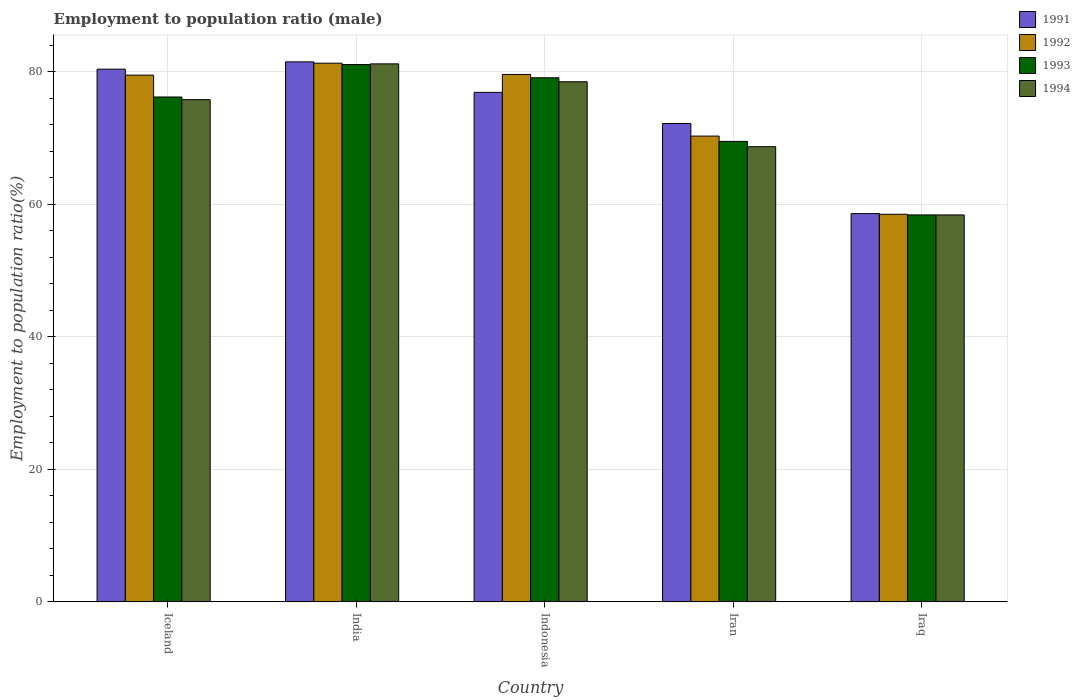How many groups of bars are there?
Provide a short and direct response. 5. Are the number of bars on each tick of the X-axis equal?
Make the answer very short. Yes. How many bars are there on the 1st tick from the right?
Your answer should be very brief. 4. What is the employment to population ratio in 1992 in India?
Your response must be concise. 81.3. Across all countries, what is the maximum employment to population ratio in 1994?
Your answer should be very brief. 81.2. Across all countries, what is the minimum employment to population ratio in 1992?
Give a very brief answer. 58.5. In which country was the employment to population ratio in 1992 minimum?
Keep it short and to the point. Iraq. What is the total employment to population ratio in 1992 in the graph?
Your response must be concise. 369.2. What is the difference between the employment to population ratio in 1991 in India and that in Indonesia?
Your response must be concise. 4.6. What is the difference between the employment to population ratio in 1991 in Iraq and the employment to population ratio in 1994 in Iceland?
Your response must be concise. -17.2. What is the average employment to population ratio in 1994 per country?
Your answer should be very brief. 72.52. What is the difference between the employment to population ratio of/in 1994 and employment to population ratio of/in 1993 in Iceland?
Provide a succinct answer. -0.4. What is the ratio of the employment to population ratio in 1991 in Iceland to that in Indonesia?
Offer a terse response. 1.05. Is the difference between the employment to population ratio in 1994 in India and Iraq greater than the difference between the employment to population ratio in 1993 in India and Iraq?
Your response must be concise. Yes. What is the difference between the highest and the second highest employment to population ratio in 1993?
Your answer should be very brief. 4.9. What is the difference between the highest and the lowest employment to population ratio in 1991?
Your answer should be compact. 22.9. Is the sum of the employment to population ratio in 1991 in Iceland and India greater than the maximum employment to population ratio in 1994 across all countries?
Your response must be concise. Yes. Is it the case that in every country, the sum of the employment to population ratio in 1994 and employment to population ratio in 1992 is greater than the sum of employment to population ratio in 1993 and employment to population ratio in 1991?
Provide a succinct answer. No. What does the 2nd bar from the right in Iceland represents?
Your answer should be compact. 1993. Are all the bars in the graph horizontal?
Your response must be concise. No. How many countries are there in the graph?
Offer a terse response. 5. Are the values on the major ticks of Y-axis written in scientific E-notation?
Your response must be concise. No. Does the graph contain grids?
Your response must be concise. Yes. What is the title of the graph?
Provide a succinct answer. Employment to population ratio (male). What is the label or title of the X-axis?
Your answer should be very brief. Country. What is the Employment to population ratio(%) in 1991 in Iceland?
Your response must be concise. 80.4. What is the Employment to population ratio(%) of 1992 in Iceland?
Make the answer very short. 79.5. What is the Employment to population ratio(%) of 1993 in Iceland?
Your answer should be compact. 76.2. What is the Employment to population ratio(%) in 1994 in Iceland?
Your response must be concise. 75.8. What is the Employment to population ratio(%) of 1991 in India?
Make the answer very short. 81.5. What is the Employment to population ratio(%) in 1992 in India?
Keep it short and to the point. 81.3. What is the Employment to population ratio(%) of 1993 in India?
Ensure brevity in your answer.  81.1. What is the Employment to population ratio(%) in 1994 in India?
Provide a short and direct response. 81.2. What is the Employment to population ratio(%) of 1991 in Indonesia?
Make the answer very short. 76.9. What is the Employment to population ratio(%) in 1992 in Indonesia?
Make the answer very short. 79.6. What is the Employment to population ratio(%) in 1993 in Indonesia?
Keep it short and to the point. 79.1. What is the Employment to population ratio(%) of 1994 in Indonesia?
Ensure brevity in your answer.  78.5. What is the Employment to population ratio(%) of 1991 in Iran?
Provide a succinct answer. 72.2. What is the Employment to population ratio(%) of 1992 in Iran?
Your answer should be compact. 70.3. What is the Employment to population ratio(%) in 1993 in Iran?
Make the answer very short. 69.5. What is the Employment to population ratio(%) in 1994 in Iran?
Keep it short and to the point. 68.7. What is the Employment to population ratio(%) of 1991 in Iraq?
Give a very brief answer. 58.6. What is the Employment to population ratio(%) of 1992 in Iraq?
Provide a short and direct response. 58.5. What is the Employment to population ratio(%) in 1993 in Iraq?
Your answer should be very brief. 58.4. What is the Employment to population ratio(%) of 1994 in Iraq?
Provide a succinct answer. 58.4. Across all countries, what is the maximum Employment to population ratio(%) in 1991?
Keep it short and to the point. 81.5. Across all countries, what is the maximum Employment to population ratio(%) in 1992?
Offer a terse response. 81.3. Across all countries, what is the maximum Employment to population ratio(%) of 1993?
Ensure brevity in your answer.  81.1. Across all countries, what is the maximum Employment to population ratio(%) in 1994?
Provide a succinct answer. 81.2. Across all countries, what is the minimum Employment to population ratio(%) of 1991?
Provide a short and direct response. 58.6. Across all countries, what is the minimum Employment to population ratio(%) of 1992?
Offer a very short reply. 58.5. Across all countries, what is the minimum Employment to population ratio(%) of 1993?
Make the answer very short. 58.4. Across all countries, what is the minimum Employment to population ratio(%) in 1994?
Make the answer very short. 58.4. What is the total Employment to population ratio(%) of 1991 in the graph?
Your answer should be compact. 369.6. What is the total Employment to population ratio(%) in 1992 in the graph?
Your response must be concise. 369.2. What is the total Employment to population ratio(%) of 1993 in the graph?
Offer a terse response. 364.3. What is the total Employment to population ratio(%) of 1994 in the graph?
Keep it short and to the point. 362.6. What is the difference between the Employment to population ratio(%) in 1992 in Iceland and that in India?
Ensure brevity in your answer.  -1.8. What is the difference between the Employment to population ratio(%) in 1993 in Iceland and that in India?
Your response must be concise. -4.9. What is the difference between the Employment to population ratio(%) in 1992 in Iceland and that in Indonesia?
Offer a very short reply. -0.1. What is the difference between the Employment to population ratio(%) of 1993 in Iceland and that in Indonesia?
Offer a terse response. -2.9. What is the difference between the Employment to population ratio(%) in 1994 in Iceland and that in Indonesia?
Ensure brevity in your answer.  -2.7. What is the difference between the Employment to population ratio(%) in 1991 in Iceland and that in Iraq?
Your response must be concise. 21.8. What is the difference between the Employment to population ratio(%) of 1991 in India and that in Indonesia?
Offer a terse response. 4.6. What is the difference between the Employment to population ratio(%) in 1992 in India and that in Indonesia?
Your answer should be very brief. 1.7. What is the difference between the Employment to population ratio(%) of 1991 in India and that in Iran?
Keep it short and to the point. 9.3. What is the difference between the Employment to population ratio(%) in 1992 in India and that in Iran?
Keep it short and to the point. 11. What is the difference between the Employment to population ratio(%) of 1993 in India and that in Iran?
Offer a very short reply. 11.6. What is the difference between the Employment to population ratio(%) of 1994 in India and that in Iran?
Offer a very short reply. 12.5. What is the difference between the Employment to population ratio(%) of 1991 in India and that in Iraq?
Your answer should be compact. 22.9. What is the difference between the Employment to population ratio(%) in 1992 in India and that in Iraq?
Your response must be concise. 22.8. What is the difference between the Employment to population ratio(%) in 1993 in India and that in Iraq?
Give a very brief answer. 22.7. What is the difference between the Employment to population ratio(%) of 1994 in India and that in Iraq?
Provide a short and direct response. 22.8. What is the difference between the Employment to population ratio(%) in 1991 in Indonesia and that in Iran?
Ensure brevity in your answer.  4.7. What is the difference between the Employment to population ratio(%) in 1994 in Indonesia and that in Iran?
Provide a succinct answer. 9.8. What is the difference between the Employment to population ratio(%) in 1992 in Indonesia and that in Iraq?
Make the answer very short. 21.1. What is the difference between the Employment to population ratio(%) of 1993 in Indonesia and that in Iraq?
Your answer should be very brief. 20.7. What is the difference between the Employment to population ratio(%) in 1994 in Indonesia and that in Iraq?
Your answer should be compact. 20.1. What is the difference between the Employment to population ratio(%) in 1993 in Iran and that in Iraq?
Provide a short and direct response. 11.1. What is the difference between the Employment to population ratio(%) in 1991 in Iceland and the Employment to population ratio(%) in 1993 in India?
Provide a succinct answer. -0.7. What is the difference between the Employment to population ratio(%) of 1991 in Iceland and the Employment to population ratio(%) of 1994 in Indonesia?
Offer a terse response. 1.9. What is the difference between the Employment to population ratio(%) of 1991 in Iceland and the Employment to population ratio(%) of 1993 in Iran?
Offer a very short reply. 10.9. What is the difference between the Employment to population ratio(%) in 1991 in Iceland and the Employment to population ratio(%) in 1994 in Iran?
Make the answer very short. 11.7. What is the difference between the Employment to population ratio(%) in 1992 in Iceland and the Employment to population ratio(%) in 1993 in Iran?
Provide a short and direct response. 10. What is the difference between the Employment to population ratio(%) in 1993 in Iceland and the Employment to population ratio(%) in 1994 in Iran?
Make the answer very short. 7.5. What is the difference between the Employment to population ratio(%) in 1991 in Iceland and the Employment to population ratio(%) in 1992 in Iraq?
Your answer should be compact. 21.9. What is the difference between the Employment to population ratio(%) in 1991 in Iceland and the Employment to population ratio(%) in 1993 in Iraq?
Keep it short and to the point. 22. What is the difference between the Employment to population ratio(%) in 1992 in Iceland and the Employment to population ratio(%) in 1993 in Iraq?
Offer a terse response. 21.1. What is the difference between the Employment to population ratio(%) in 1992 in Iceland and the Employment to population ratio(%) in 1994 in Iraq?
Keep it short and to the point. 21.1. What is the difference between the Employment to population ratio(%) in 1993 in Iceland and the Employment to population ratio(%) in 1994 in Iraq?
Make the answer very short. 17.8. What is the difference between the Employment to population ratio(%) of 1991 in India and the Employment to population ratio(%) of 1993 in Iran?
Keep it short and to the point. 12. What is the difference between the Employment to population ratio(%) of 1992 in India and the Employment to population ratio(%) of 1993 in Iran?
Your answer should be very brief. 11.8. What is the difference between the Employment to population ratio(%) of 1992 in India and the Employment to population ratio(%) of 1994 in Iran?
Offer a very short reply. 12.6. What is the difference between the Employment to population ratio(%) in 1993 in India and the Employment to population ratio(%) in 1994 in Iran?
Your answer should be very brief. 12.4. What is the difference between the Employment to population ratio(%) of 1991 in India and the Employment to population ratio(%) of 1993 in Iraq?
Ensure brevity in your answer.  23.1. What is the difference between the Employment to population ratio(%) in 1991 in India and the Employment to population ratio(%) in 1994 in Iraq?
Provide a short and direct response. 23.1. What is the difference between the Employment to population ratio(%) in 1992 in India and the Employment to population ratio(%) in 1993 in Iraq?
Make the answer very short. 22.9. What is the difference between the Employment to population ratio(%) in 1992 in India and the Employment to population ratio(%) in 1994 in Iraq?
Make the answer very short. 22.9. What is the difference between the Employment to population ratio(%) of 1993 in India and the Employment to population ratio(%) of 1994 in Iraq?
Give a very brief answer. 22.7. What is the difference between the Employment to population ratio(%) in 1991 in Indonesia and the Employment to population ratio(%) in 1992 in Iran?
Offer a terse response. 6.6. What is the difference between the Employment to population ratio(%) of 1991 in Indonesia and the Employment to population ratio(%) of 1994 in Iran?
Offer a very short reply. 8.2. What is the difference between the Employment to population ratio(%) of 1993 in Indonesia and the Employment to population ratio(%) of 1994 in Iran?
Offer a very short reply. 10.4. What is the difference between the Employment to population ratio(%) in 1991 in Indonesia and the Employment to population ratio(%) in 1992 in Iraq?
Give a very brief answer. 18.4. What is the difference between the Employment to population ratio(%) of 1991 in Indonesia and the Employment to population ratio(%) of 1994 in Iraq?
Your answer should be compact. 18.5. What is the difference between the Employment to population ratio(%) of 1992 in Indonesia and the Employment to population ratio(%) of 1993 in Iraq?
Give a very brief answer. 21.2. What is the difference between the Employment to population ratio(%) in 1992 in Indonesia and the Employment to population ratio(%) in 1994 in Iraq?
Keep it short and to the point. 21.2. What is the difference between the Employment to population ratio(%) in 1993 in Indonesia and the Employment to population ratio(%) in 1994 in Iraq?
Make the answer very short. 20.7. What is the difference between the Employment to population ratio(%) in 1991 in Iran and the Employment to population ratio(%) in 1993 in Iraq?
Ensure brevity in your answer.  13.8. What is the difference between the Employment to population ratio(%) in 1991 in Iran and the Employment to population ratio(%) in 1994 in Iraq?
Offer a terse response. 13.8. What is the difference between the Employment to population ratio(%) of 1992 in Iran and the Employment to population ratio(%) of 1993 in Iraq?
Ensure brevity in your answer.  11.9. What is the average Employment to population ratio(%) of 1991 per country?
Give a very brief answer. 73.92. What is the average Employment to population ratio(%) of 1992 per country?
Ensure brevity in your answer.  73.84. What is the average Employment to population ratio(%) in 1993 per country?
Provide a short and direct response. 72.86. What is the average Employment to population ratio(%) of 1994 per country?
Ensure brevity in your answer.  72.52. What is the difference between the Employment to population ratio(%) of 1991 and Employment to population ratio(%) of 1992 in Iceland?
Give a very brief answer. 0.9. What is the difference between the Employment to population ratio(%) in 1992 and Employment to population ratio(%) in 1993 in Iceland?
Your answer should be compact. 3.3. What is the difference between the Employment to population ratio(%) in 1993 and Employment to population ratio(%) in 1994 in Iceland?
Your answer should be compact. 0.4. What is the difference between the Employment to population ratio(%) of 1991 and Employment to population ratio(%) of 1994 in India?
Make the answer very short. 0.3. What is the difference between the Employment to population ratio(%) in 1992 and Employment to population ratio(%) in 1994 in India?
Ensure brevity in your answer.  0.1. What is the difference between the Employment to population ratio(%) in 1993 and Employment to population ratio(%) in 1994 in India?
Your answer should be very brief. -0.1. What is the difference between the Employment to population ratio(%) of 1991 and Employment to population ratio(%) of 1992 in Indonesia?
Offer a terse response. -2.7. What is the difference between the Employment to population ratio(%) in 1992 and Employment to population ratio(%) in 1993 in Indonesia?
Provide a short and direct response. 0.5. What is the difference between the Employment to population ratio(%) in 1992 and Employment to population ratio(%) in 1994 in Indonesia?
Keep it short and to the point. 1.1. What is the difference between the Employment to population ratio(%) of 1993 and Employment to population ratio(%) of 1994 in Indonesia?
Provide a succinct answer. 0.6. What is the difference between the Employment to population ratio(%) of 1991 and Employment to population ratio(%) of 1993 in Iran?
Provide a short and direct response. 2.7. What is the difference between the Employment to population ratio(%) in 1992 and Employment to population ratio(%) in 1993 in Iran?
Your answer should be compact. 0.8. What is the difference between the Employment to population ratio(%) of 1992 and Employment to population ratio(%) of 1994 in Iran?
Your answer should be very brief. 1.6. What is the difference between the Employment to population ratio(%) in 1993 and Employment to population ratio(%) in 1994 in Iran?
Offer a very short reply. 0.8. What is the difference between the Employment to population ratio(%) in 1991 and Employment to population ratio(%) in 1992 in Iraq?
Your answer should be very brief. 0.1. What is the difference between the Employment to population ratio(%) in 1992 and Employment to population ratio(%) in 1993 in Iraq?
Offer a very short reply. 0.1. What is the difference between the Employment to population ratio(%) of 1992 and Employment to population ratio(%) of 1994 in Iraq?
Your answer should be very brief. 0.1. What is the ratio of the Employment to population ratio(%) of 1991 in Iceland to that in India?
Offer a very short reply. 0.99. What is the ratio of the Employment to population ratio(%) in 1992 in Iceland to that in India?
Ensure brevity in your answer.  0.98. What is the ratio of the Employment to population ratio(%) in 1993 in Iceland to that in India?
Provide a short and direct response. 0.94. What is the ratio of the Employment to population ratio(%) in 1994 in Iceland to that in India?
Provide a succinct answer. 0.93. What is the ratio of the Employment to population ratio(%) in 1991 in Iceland to that in Indonesia?
Your answer should be very brief. 1.05. What is the ratio of the Employment to population ratio(%) in 1993 in Iceland to that in Indonesia?
Provide a succinct answer. 0.96. What is the ratio of the Employment to population ratio(%) in 1994 in Iceland to that in Indonesia?
Your response must be concise. 0.97. What is the ratio of the Employment to population ratio(%) of 1991 in Iceland to that in Iran?
Your answer should be very brief. 1.11. What is the ratio of the Employment to population ratio(%) of 1992 in Iceland to that in Iran?
Provide a short and direct response. 1.13. What is the ratio of the Employment to population ratio(%) of 1993 in Iceland to that in Iran?
Your response must be concise. 1.1. What is the ratio of the Employment to population ratio(%) in 1994 in Iceland to that in Iran?
Keep it short and to the point. 1.1. What is the ratio of the Employment to population ratio(%) in 1991 in Iceland to that in Iraq?
Provide a succinct answer. 1.37. What is the ratio of the Employment to population ratio(%) of 1992 in Iceland to that in Iraq?
Give a very brief answer. 1.36. What is the ratio of the Employment to population ratio(%) in 1993 in Iceland to that in Iraq?
Offer a terse response. 1.3. What is the ratio of the Employment to population ratio(%) in 1994 in Iceland to that in Iraq?
Provide a short and direct response. 1.3. What is the ratio of the Employment to population ratio(%) of 1991 in India to that in Indonesia?
Your response must be concise. 1.06. What is the ratio of the Employment to population ratio(%) in 1992 in India to that in Indonesia?
Offer a terse response. 1.02. What is the ratio of the Employment to population ratio(%) in 1993 in India to that in Indonesia?
Your answer should be very brief. 1.03. What is the ratio of the Employment to population ratio(%) of 1994 in India to that in Indonesia?
Ensure brevity in your answer.  1.03. What is the ratio of the Employment to population ratio(%) in 1991 in India to that in Iran?
Your answer should be compact. 1.13. What is the ratio of the Employment to population ratio(%) in 1992 in India to that in Iran?
Offer a terse response. 1.16. What is the ratio of the Employment to population ratio(%) in 1993 in India to that in Iran?
Offer a terse response. 1.17. What is the ratio of the Employment to population ratio(%) in 1994 in India to that in Iran?
Offer a terse response. 1.18. What is the ratio of the Employment to population ratio(%) in 1991 in India to that in Iraq?
Your answer should be compact. 1.39. What is the ratio of the Employment to population ratio(%) of 1992 in India to that in Iraq?
Ensure brevity in your answer.  1.39. What is the ratio of the Employment to population ratio(%) of 1993 in India to that in Iraq?
Your answer should be compact. 1.39. What is the ratio of the Employment to population ratio(%) of 1994 in India to that in Iraq?
Your answer should be very brief. 1.39. What is the ratio of the Employment to population ratio(%) in 1991 in Indonesia to that in Iran?
Provide a succinct answer. 1.07. What is the ratio of the Employment to population ratio(%) of 1992 in Indonesia to that in Iran?
Ensure brevity in your answer.  1.13. What is the ratio of the Employment to population ratio(%) in 1993 in Indonesia to that in Iran?
Keep it short and to the point. 1.14. What is the ratio of the Employment to population ratio(%) in 1994 in Indonesia to that in Iran?
Your answer should be very brief. 1.14. What is the ratio of the Employment to population ratio(%) of 1991 in Indonesia to that in Iraq?
Provide a succinct answer. 1.31. What is the ratio of the Employment to population ratio(%) in 1992 in Indonesia to that in Iraq?
Provide a short and direct response. 1.36. What is the ratio of the Employment to population ratio(%) in 1993 in Indonesia to that in Iraq?
Give a very brief answer. 1.35. What is the ratio of the Employment to population ratio(%) in 1994 in Indonesia to that in Iraq?
Give a very brief answer. 1.34. What is the ratio of the Employment to population ratio(%) of 1991 in Iran to that in Iraq?
Give a very brief answer. 1.23. What is the ratio of the Employment to population ratio(%) of 1992 in Iran to that in Iraq?
Make the answer very short. 1.2. What is the ratio of the Employment to population ratio(%) in 1993 in Iran to that in Iraq?
Offer a terse response. 1.19. What is the ratio of the Employment to population ratio(%) in 1994 in Iran to that in Iraq?
Your answer should be compact. 1.18. What is the difference between the highest and the second highest Employment to population ratio(%) of 1991?
Your response must be concise. 1.1. What is the difference between the highest and the second highest Employment to population ratio(%) of 1992?
Provide a succinct answer. 1.7. What is the difference between the highest and the second highest Employment to population ratio(%) of 1993?
Keep it short and to the point. 2. What is the difference between the highest and the lowest Employment to population ratio(%) in 1991?
Ensure brevity in your answer.  22.9. What is the difference between the highest and the lowest Employment to population ratio(%) of 1992?
Your response must be concise. 22.8. What is the difference between the highest and the lowest Employment to population ratio(%) of 1993?
Provide a short and direct response. 22.7. What is the difference between the highest and the lowest Employment to population ratio(%) in 1994?
Your response must be concise. 22.8. 